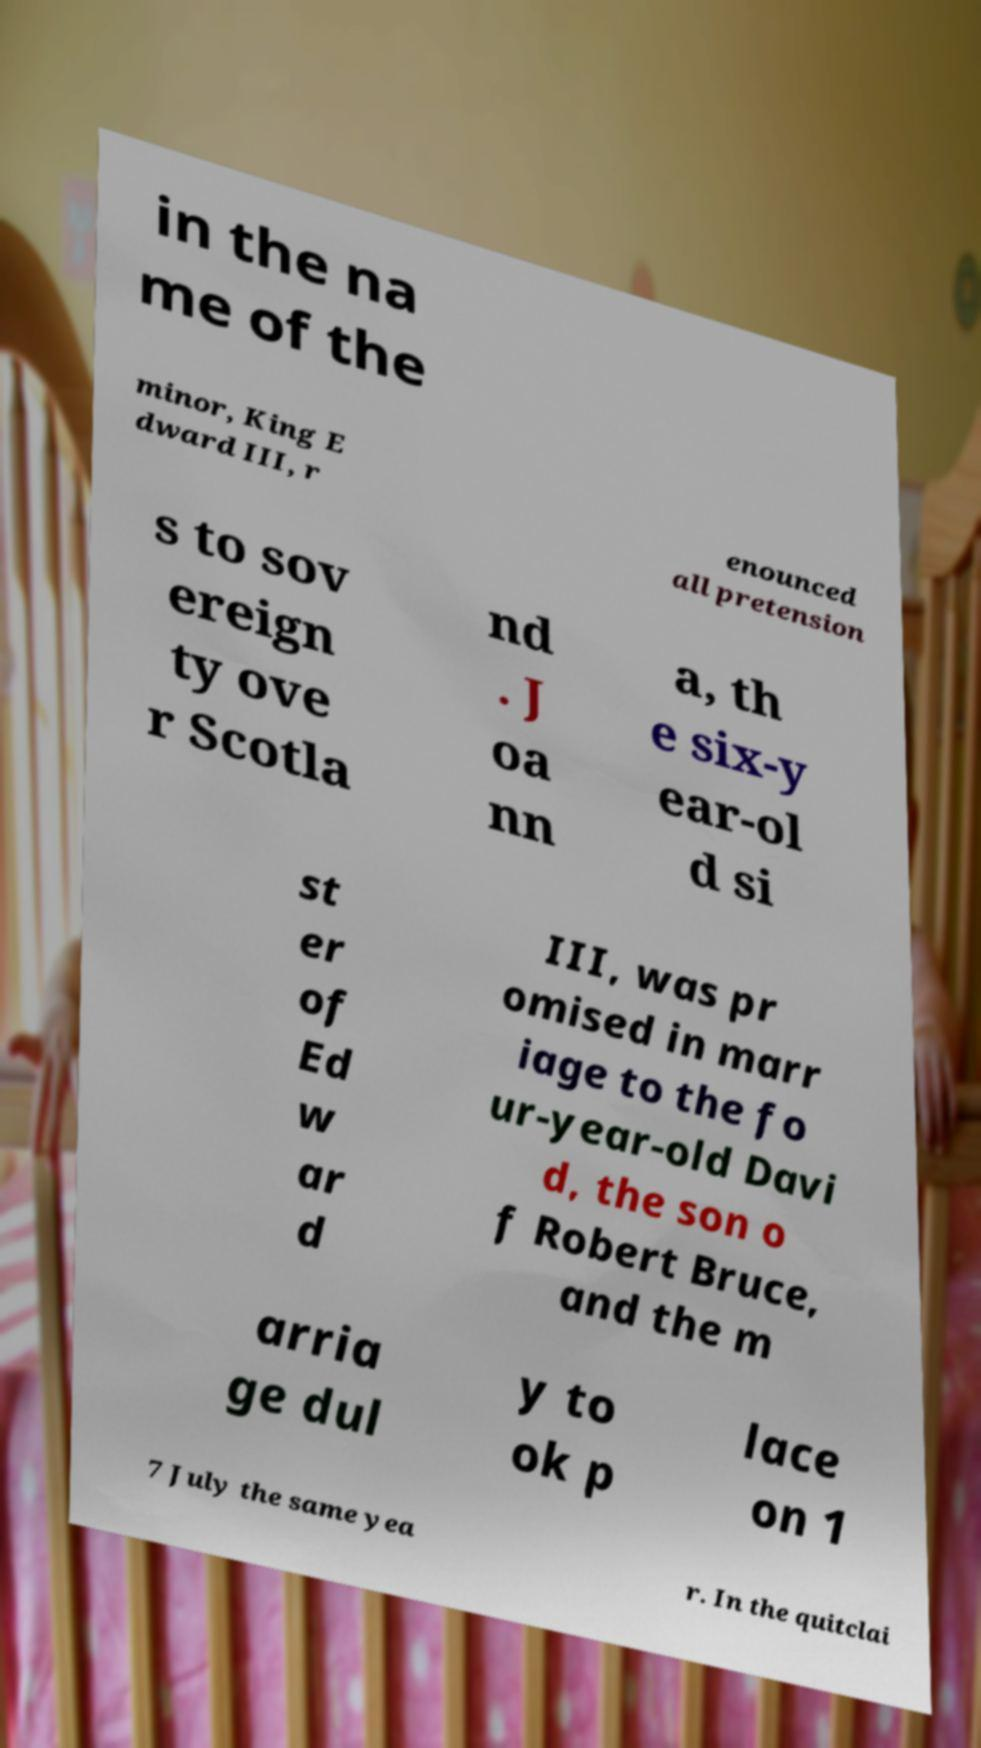Please read and relay the text visible in this image. What does it say? in the na me of the minor, King E dward III, r enounced all pretension s to sov ereign ty ove r Scotla nd . J oa nn a, th e six-y ear-ol d si st er of Ed w ar d III, was pr omised in marr iage to the fo ur-year-old Davi d, the son o f Robert Bruce, and the m arria ge dul y to ok p lace on 1 7 July the same yea r. In the quitclai 